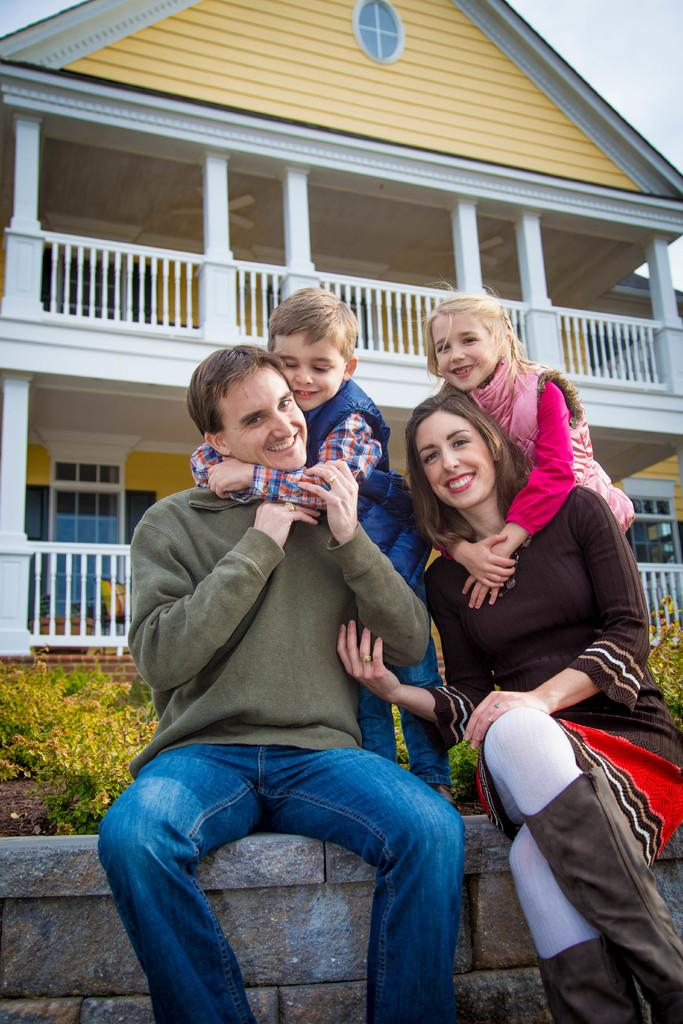What is the main subject in the front of the image? There is a group of people in the front of the image. What type of vegetation can be seen in the image? There is grass in the image. What is the purpose of the structure in the image? There is a fence in the image, which may serve as a boundary or barrier. What type of building is present in the image? There is a house in the image. What is visible in the background of the image? The sky is visible in the image. How does the group of people tie a knot in the image? There is no knot-tying activity depicted in the image; the group of people is simply standing in the front. 